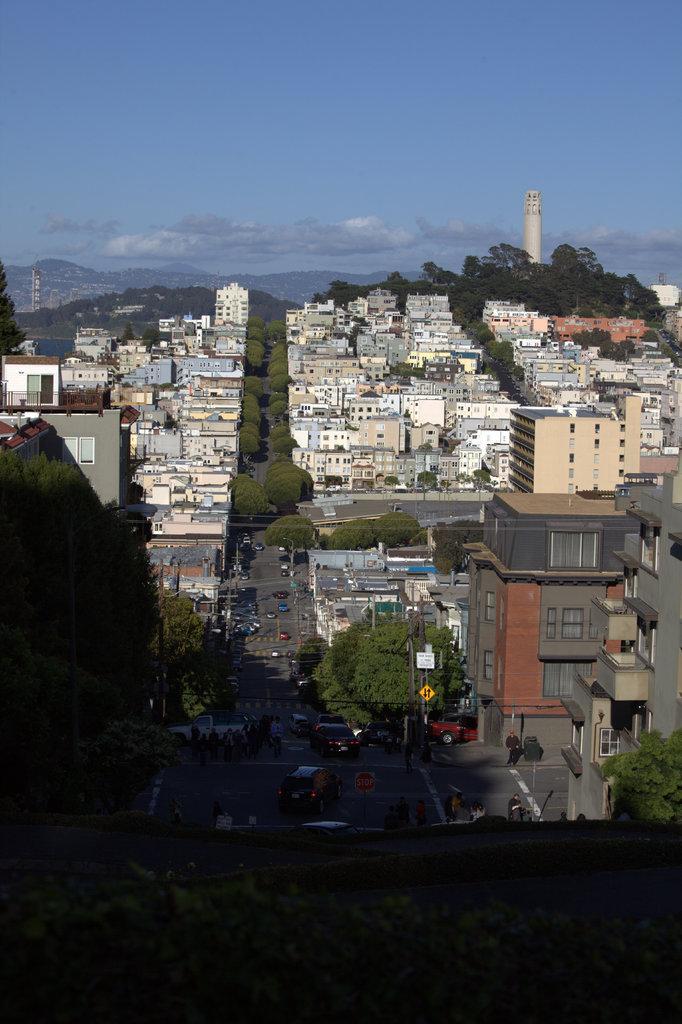Describe this image in one or two sentences. In this picture we can observe houses. There is a road. We can observe trees in this picture. On the right side there is a tower. In the background there are hills and a sky with clouds. 